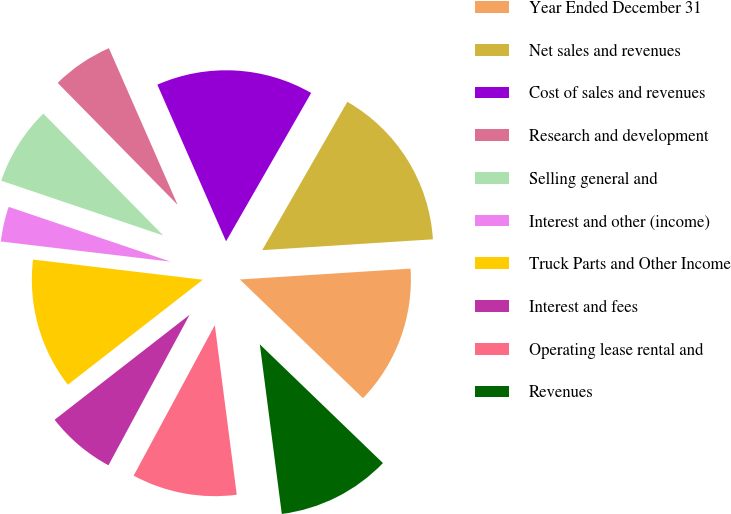Convert chart to OTSL. <chart><loc_0><loc_0><loc_500><loc_500><pie_chart><fcel>Year Ended December 31<fcel>Net sales and revenues<fcel>Cost of sales and revenues<fcel>Research and development<fcel>Selling general and<fcel>Interest and other (income)<fcel>Truck Parts and Other Income<fcel>Interest and fees<fcel>Operating lease rental and<fcel>Revenues<nl><fcel>13.22%<fcel>15.7%<fcel>14.87%<fcel>5.79%<fcel>7.44%<fcel>3.31%<fcel>12.4%<fcel>6.61%<fcel>9.92%<fcel>10.74%<nl></chart> 